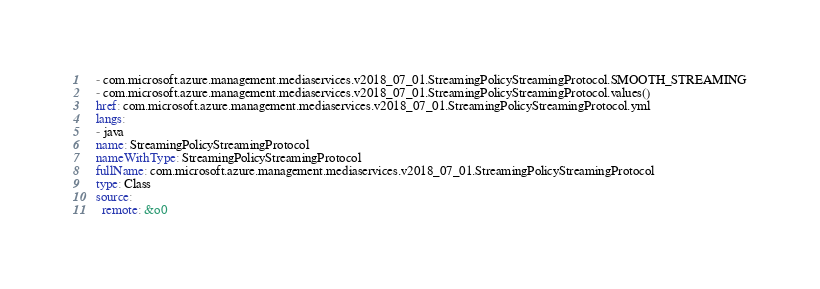Convert code to text. <code><loc_0><loc_0><loc_500><loc_500><_YAML_>  - com.microsoft.azure.management.mediaservices.v2018_07_01.StreamingPolicyStreamingProtocol.SMOOTH_STREAMING
  - com.microsoft.azure.management.mediaservices.v2018_07_01.StreamingPolicyStreamingProtocol.values()
  href: com.microsoft.azure.management.mediaservices.v2018_07_01.StreamingPolicyStreamingProtocol.yml
  langs:
  - java
  name: StreamingPolicyStreamingProtocol
  nameWithType: StreamingPolicyStreamingProtocol
  fullName: com.microsoft.azure.management.mediaservices.v2018_07_01.StreamingPolicyStreamingProtocol
  type: Class
  source:
    remote: &o0</code> 